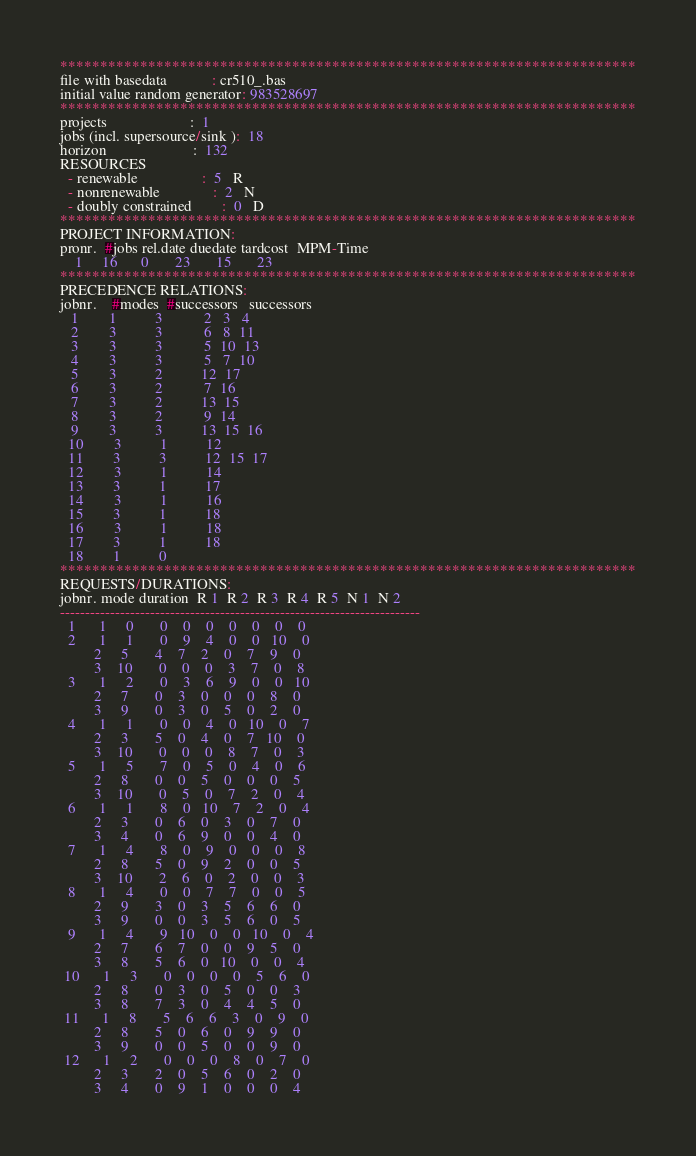Convert code to text. <code><loc_0><loc_0><loc_500><loc_500><_ObjectiveC_>************************************************************************
file with basedata            : cr510_.bas
initial value random generator: 983528697
************************************************************************
projects                      :  1
jobs (incl. supersource/sink ):  18
horizon                       :  132
RESOURCES
  - renewable                 :  5   R
  - nonrenewable              :  2   N
  - doubly constrained        :  0   D
************************************************************************
PROJECT INFORMATION:
pronr.  #jobs rel.date duedate tardcost  MPM-Time
    1     16      0       23       15       23
************************************************************************
PRECEDENCE RELATIONS:
jobnr.    #modes  #successors   successors
   1        1          3           2   3   4
   2        3          3           6   8  11
   3        3          3           5  10  13
   4        3          3           5   7  10
   5        3          2          12  17
   6        3          2           7  16
   7        3          2          13  15
   8        3          2           9  14
   9        3          3          13  15  16
  10        3          1          12
  11        3          3          12  15  17
  12        3          1          14
  13        3          1          17
  14        3          1          16
  15        3          1          18
  16        3          1          18
  17        3          1          18
  18        1          0        
************************************************************************
REQUESTS/DURATIONS:
jobnr. mode duration  R 1  R 2  R 3  R 4  R 5  N 1  N 2
------------------------------------------------------------------------
  1      1     0       0    0    0    0    0    0    0
  2      1     1       0    9    4    0    0   10    0
         2     5       4    7    2    0    7    9    0
         3    10       0    0    0    3    7    0    8
  3      1     2       0    3    6    9    0    0   10
         2     7       0    3    0    0    0    8    0
         3     9       0    3    0    5    0    2    0
  4      1     1       0    0    4    0   10    0    7
         2     3       5    0    4    0    7   10    0
         3    10       0    0    0    8    7    0    3
  5      1     5       7    0    5    0    4    0    6
         2     8       0    0    5    0    0    0    5
         3    10       0    5    0    7    2    0    4
  6      1     1       8    0   10    7    2    0    4
         2     3       0    6    0    3    0    7    0
         3     4       0    6    9    0    0    4    0
  7      1     4       8    0    9    0    0    0    8
         2     8       5    0    9    2    0    0    5
         3    10       2    6    0    2    0    0    3
  8      1     4       0    0    7    7    0    0    5
         2     9       3    0    3    5    6    6    0
         3     9       0    0    3    5    6    0    5
  9      1     4       9   10    0    0   10    0    4
         2     7       6    7    0    0    9    5    0
         3     8       5    6    0   10    0    0    4
 10      1     3       0    0    0    0    5    6    0
         2     8       0    3    0    5    0    0    3
         3     8       7    3    0    4    4    5    0
 11      1     8       5    6    6    3    0    9    0
         2     8       5    0    6    0    9    9    0
         3     9       0    0    5    0    0    9    0
 12      1     2       0    0    0    8    0    7    0
         2     3       2    0    5    6    0    2    0
         3     4       0    9    1    0    0    0    4</code> 